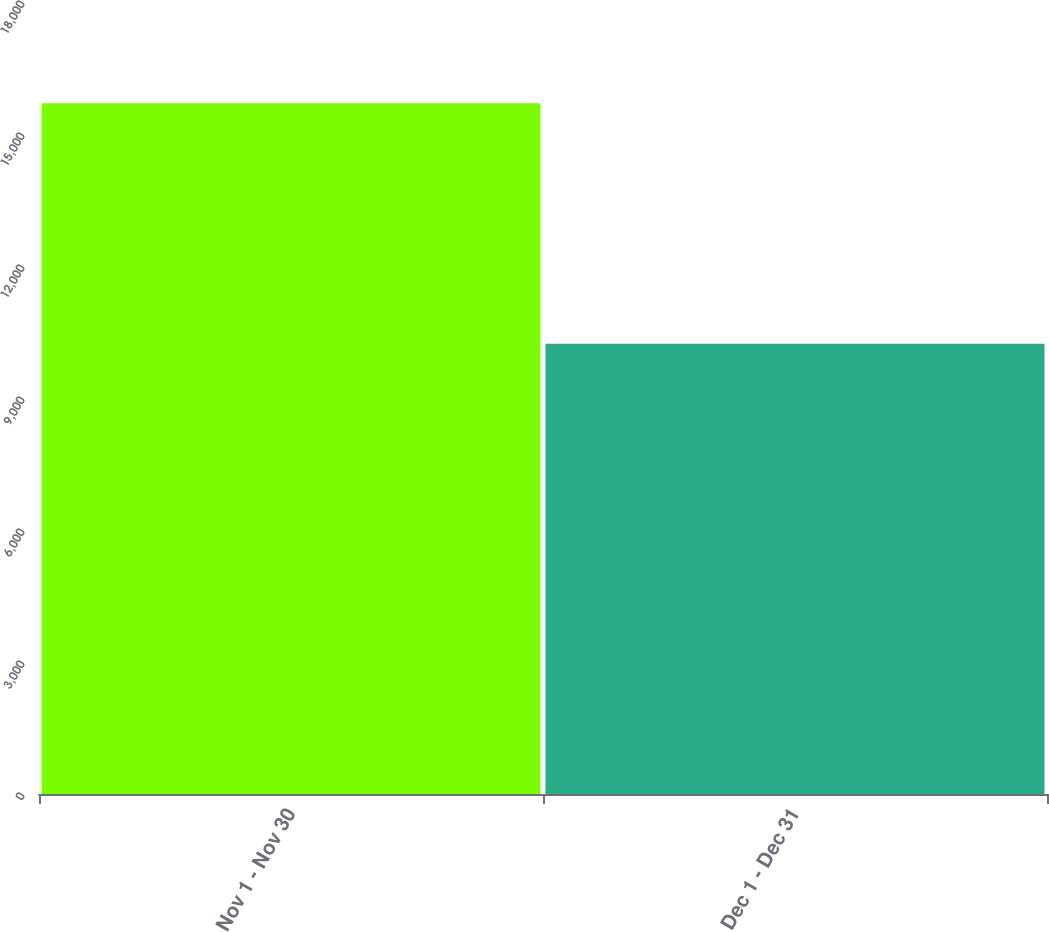<chart> <loc_0><loc_0><loc_500><loc_500><bar_chart><fcel>Nov 1 - Nov 30<fcel>Dec 1 - Dec 31<nl><fcel>15698<fcel>10231<nl></chart> 